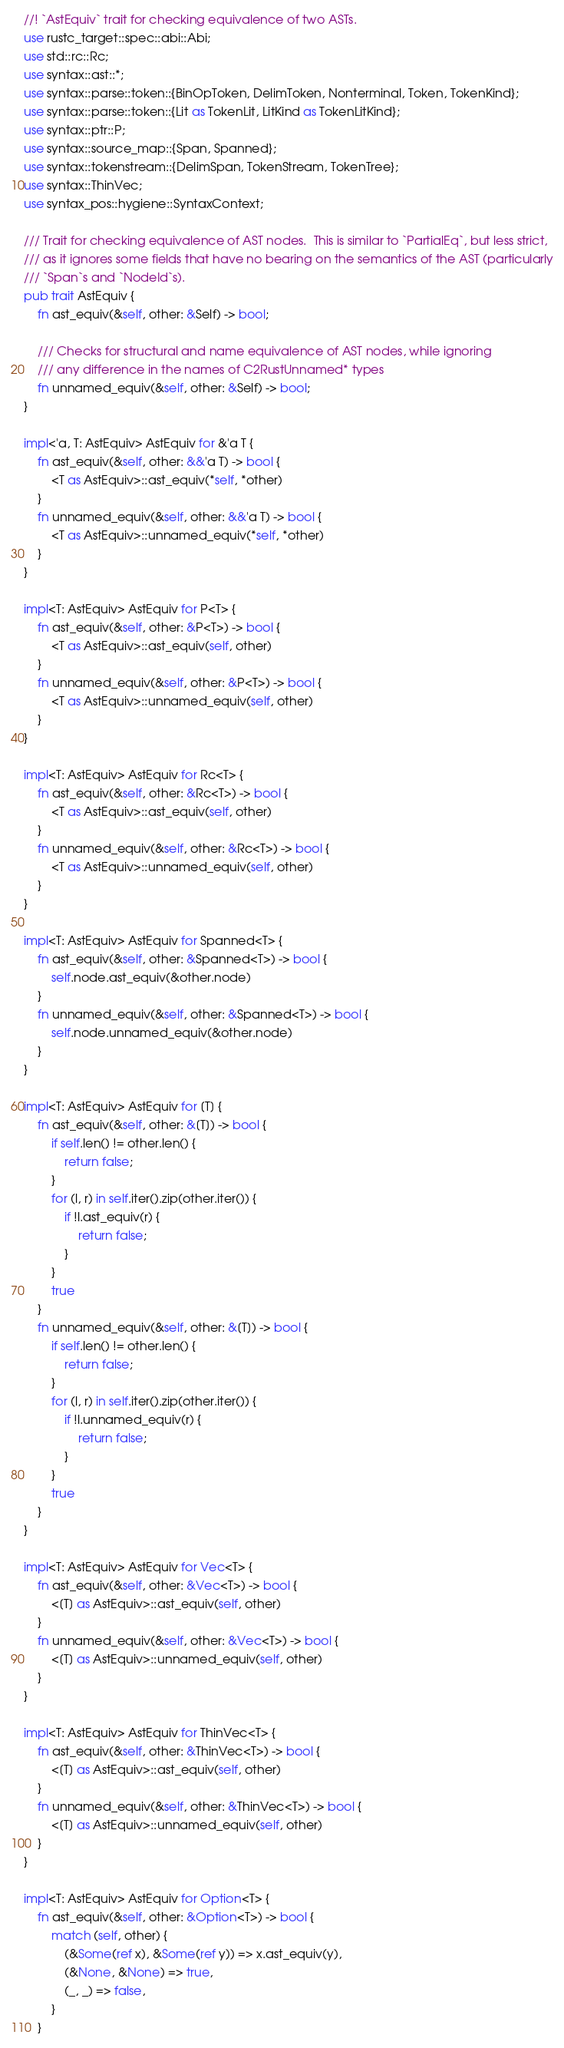<code> <loc_0><loc_0><loc_500><loc_500><_Rust_>//! `AstEquiv` trait for checking equivalence of two ASTs.
use rustc_target::spec::abi::Abi;
use std::rc::Rc;
use syntax::ast::*;
use syntax::parse::token::{BinOpToken, DelimToken, Nonterminal, Token, TokenKind};
use syntax::parse::token::{Lit as TokenLit, LitKind as TokenLitKind};
use syntax::ptr::P;
use syntax::source_map::{Span, Spanned};
use syntax::tokenstream::{DelimSpan, TokenStream, TokenTree};
use syntax::ThinVec;
use syntax_pos::hygiene::SyntaxContext;

/// Trait for checking equivalence of AST nodes.  This is similar to `PartialEq`, but less strict,
/// as it ignores some fields that have no bearing on the semantics of the AST (particularly
/// `Span`s and `NodeId`s).
pub trait AstEquiv {
    fn ast_equiv(&self, other: &Self) -> bool;

    /// Checks for structural and name equivalence of AST nodes, while ignoring
    /// any difference in the names of C2RustUnnamed* types
    fn unnamed_equiv(&self, other: &Self) -> bool;
}

impl<'a, T: AstEquiv> AstEquiv for &'a T {
    fn ast_equiv(&self, other: &&'a T) -> bool {
        <T as AstEquiv>::ast_equiv(*self, *other)
    }
    fn unnamed_equiv(&self, other: &&'a T) -> bool {
        <T as AstEquiv>::unnamed_equiv(*self, *other)
    }
}

impl<T: AstEquiv> AstEquiv for P<T> {
    fn ast_equiv(&self, other: &P<T>) -> bool {
        <T as AstEquiv>::ast_equiv(self, other)
    }
    fn unnamed_equiv(&self, other: &P<T>) -> bool {
        <T as AstEquiv>::unnamed_equiv(self, other)
    }
}

impl<T: AstEquiv> AstEquiv for Rc<T> {
    fn ast_equiv(&self, other: &Rc<T>) -> bool {
        <T as AstEquiv>::ast_equiv(self, other)
    }
    fn unnamed_equiv(&self, other: &Rc<T>) -> bool {
        <T as AstEquiv>::unnamed_equiv(self, other)
    }
}

impl<T: AstEquiv> AstEquiv for Spanned<T> {
    fn ast_equiv(&self, other: &Spanned<T>) -> bool {
        self.node.ast_equiv(&other.node)
    }
    fn unnamed_equiv(&self, other: &Spanned<T>) -> bool {
        self.node.unnamed_equiv(&other.node)
    }
}

impl<T: AstEquiv> AstEquiv for [T] {
    fn ast_equiv(&self, other: &[T]) -> bool {
        if self.len() != other.len() {
            return false;
        }
        for (l, r) in self.iter().zip(other.iter()) {
            if !l.ast_equiv(r) {
                return false;
            }
        }
        true
    }
    fn unnamed_equiv(&self, other: &[T]) -> bool {
        if self.len() != other.len() {
            return false;
        }
        for (l, r) in self.iter().zip(other.iter()) {
            if !l.unnamed_equiv(r) {
                return false;
            }
        }
        true
    }
}

impl<T: AstEquiv> AstEquiv for Vec<T> {
    fn ast_equiv(&self, other: &Vec<T>) -> bool {
        <[T] as AstEquiv>::ast_equiv(self, other)
    }
    fn unnamed_equiv(&self, other: &Vec<T>) -> bool {
        <[T] as AstEquiv>::unnamed_equiv(self, other)
    }
}

impl<T: AstEquiv> AstEquiv for ThinVec<T> {
    fn ast_equiv(&self, other: &ThinVec<T>) -> bool {
        <[T] as AstEquiv>::ast_equiv(self, other)
    }
    fn unnamed_equiv(&self, other: &ThinVec<T>) -> bool {
        <[T] as AstEquiv>::unnamed_equiv(self, other)
    }
}

impl<T: AstEquiv> AstEquiv for Option<T> {
    fn ast_equiv(&self, other: &Option<T>) -> bool {
        match (self, other) {
            (&Some(ref x), &Some(ref y)) => x.ast_equiv(y),
            (&None, &None) => true,
            (_, _) => false,
        }
    }</code> 